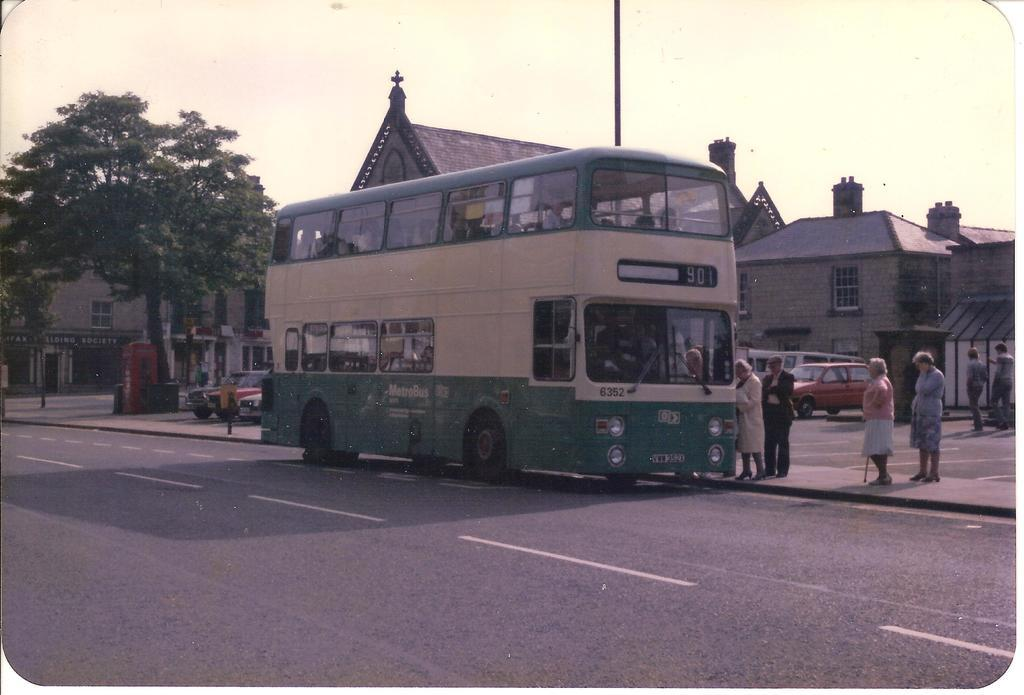What can be seen in the image involving people? There are people standing in the image. What else is present in the image besides people? There are vehicles, buildings, trees, and a road in the image. What is visible at the top of the image? The sky is visible in the image. What year is depicted in the image? The year is not depicted in the image, as it does not contain any specific date or time reference. Can you tell me how the trees are playing in the image? Trees do not play, as they are inanimate objects. The image simply shows trees as part of the landscape. 